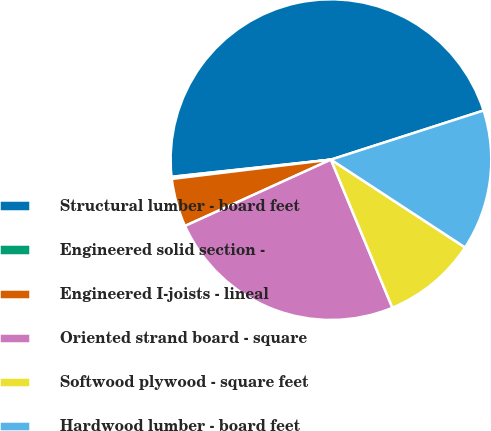Convert chart. <chart><loc_0><loc_0><loc_500><loc_500><pie_chart><fcel>Structural lumber - board feet<fcel>Engineered solid section -<fcel>Engineered I-joists - lineal<fcel>Oriented strand board - square<fcel>Softwood plywood - square feet<fcel>Hardwood lumber - board feet<nl><fcel>46.76%<fcel>0.21%<fcel>4.87%<fcel>24.47%<fcel>9.52%<fcel>14.18%<nl></chart> 